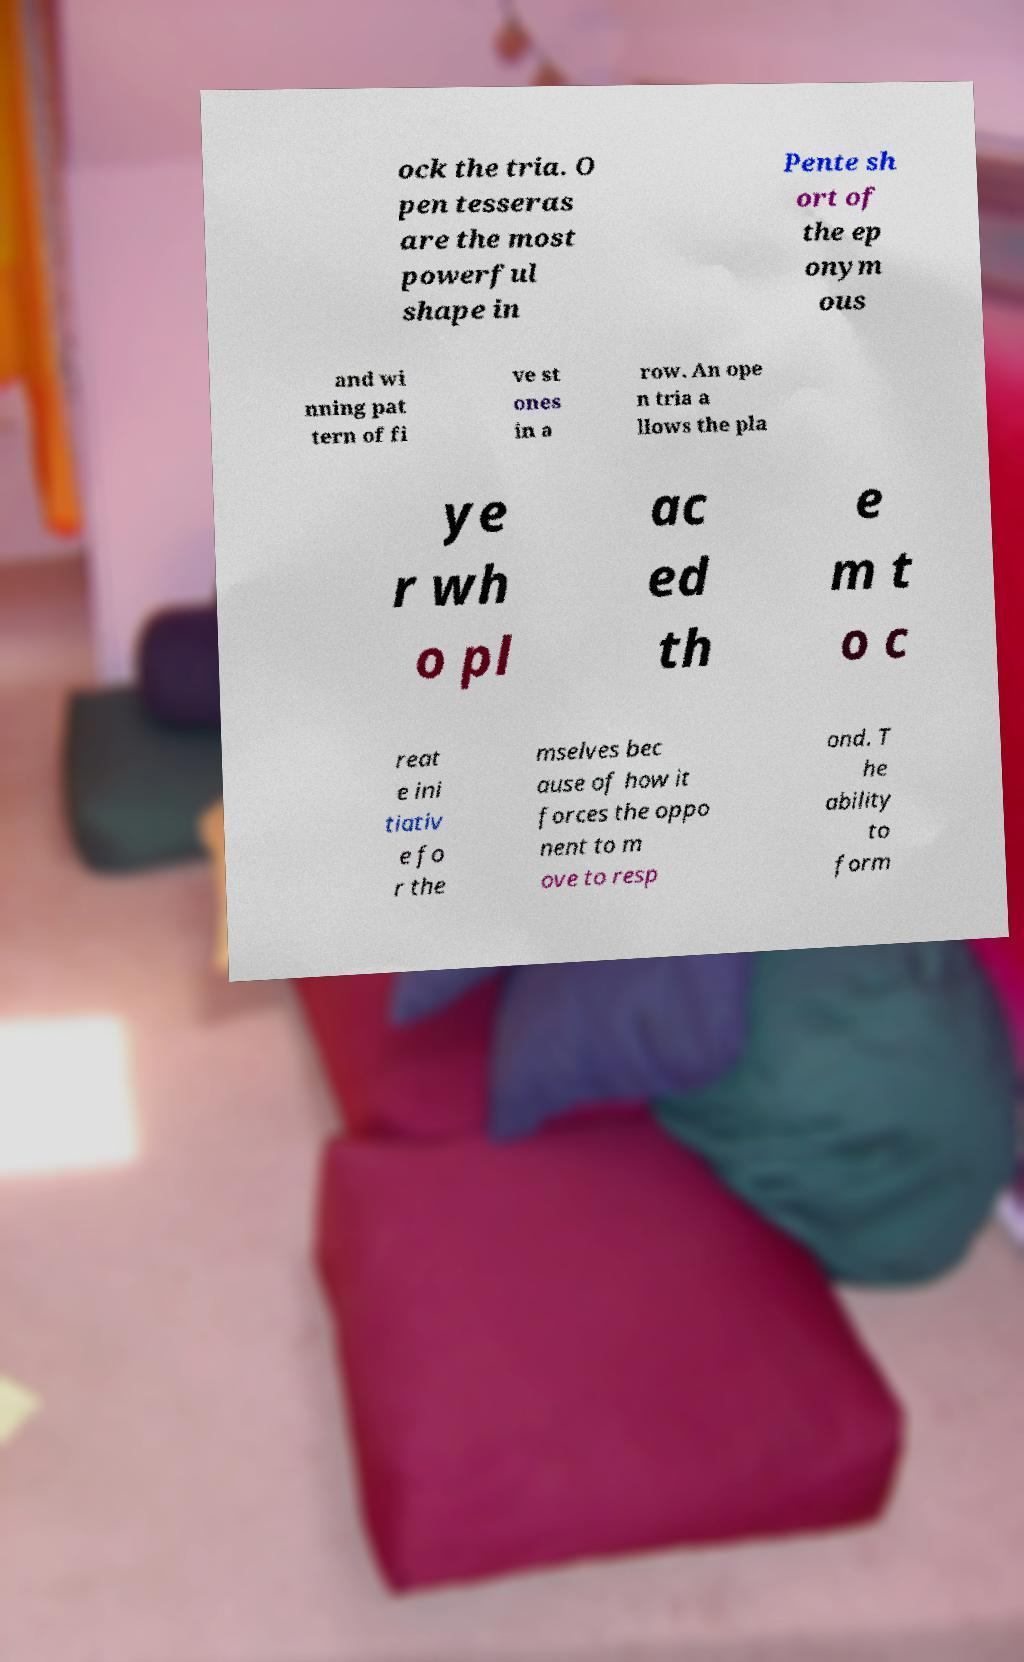Can you accurately transcribe the text from the provided image for me? ock the tria. O pen tesseras are the most powerful shape in Pente sh ort of the ep onym ous and wi nning pat tern of fi ve st ones in a row. An ope n tria a llows the pla ye r wh o pl ac ed th e m t o c reat e ini tiativ e fo r the mselves bec ause of how it forces the oppo nent to m ove to resp ond. T he ability to form 